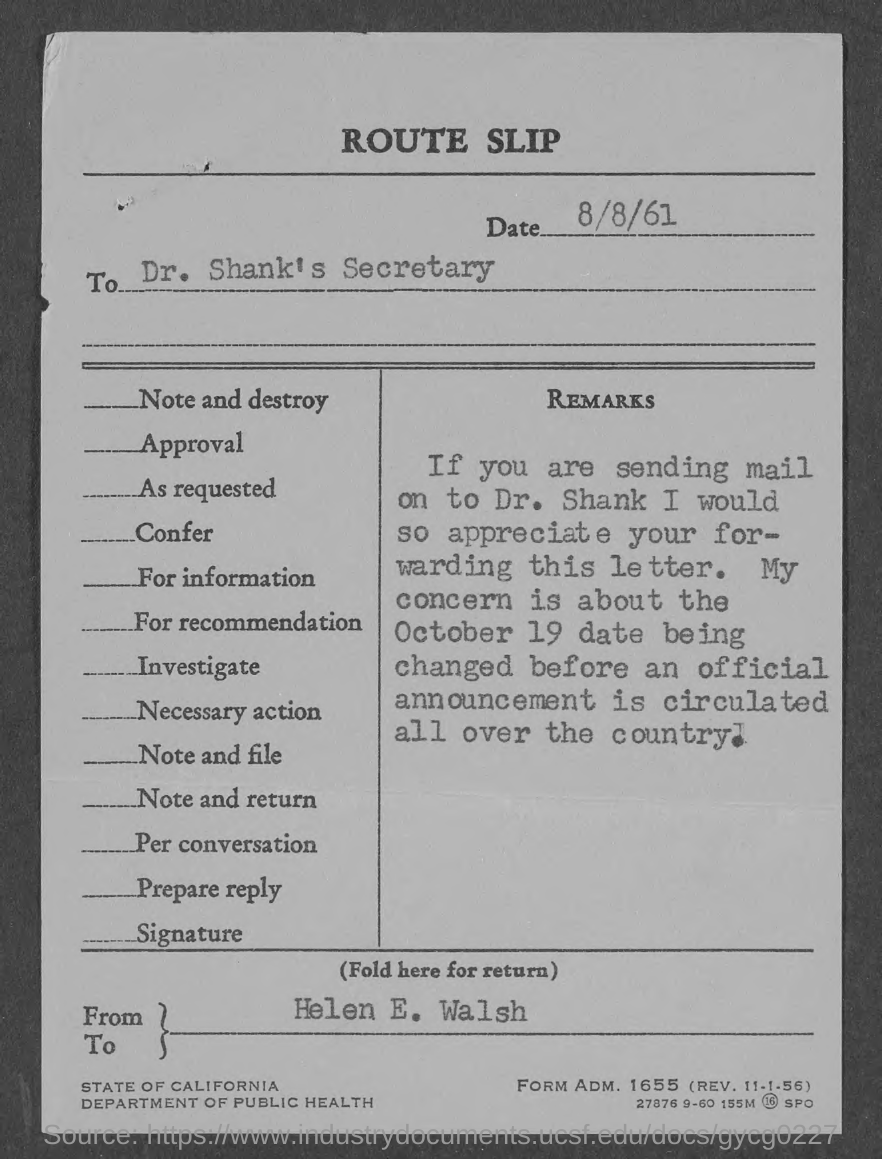Indicate a few pertinent items in this graphic. The form mentioned in the given route slip is "adm. no." The adm. no. is 1655... The letter was written to Dr. Shank's secretary. The department mentioned in the given route slip is the Department of Public Health. The date mentioned on the route slip is August 8, 1961. 